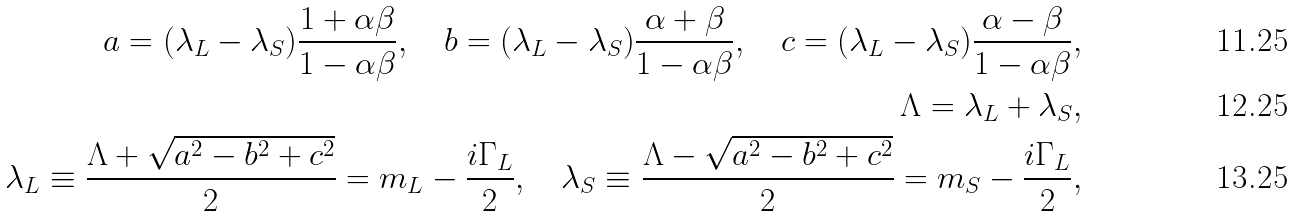<formula> <loc_0><loc_0><loc_500><loc_500>a = ( \lambda _ { L } - \lambda _ { S } ) \frac { 1 + \alpha \beta } { 1 - \alpha \beta } , \quad b = ( \lambda _ { L } - \lambda _ { S } ) \frac { \alpha + \beta } { 1 - \alpha \beta } , \quad c = ( \lambda _ { L } - \lambda _ { S } ) \frac { \alpha - \beta } { 1 - \alpha \beta } , \\ \Lambda = \lambda _ { L } + \lambda _ { S } , \\ \lambda _ { L } \equiv \frac { \Lambda + \sqrt { a ^ { 2 } - b ^ { 2 } + c ^ { 2 } } } { 2 } = m _ { L } - \frac { i \Gamma _ { L } } { 2 } , \quad \lambda _ { S } \equiv \frac { \Lambda - \sqrt { a ^ { 2 } - b ^ { 2 } + c ^ { 2 } } } { 2 } = m _ { S } - \frac { i \Gamma _ { L } } { 2 } ,</formula> 